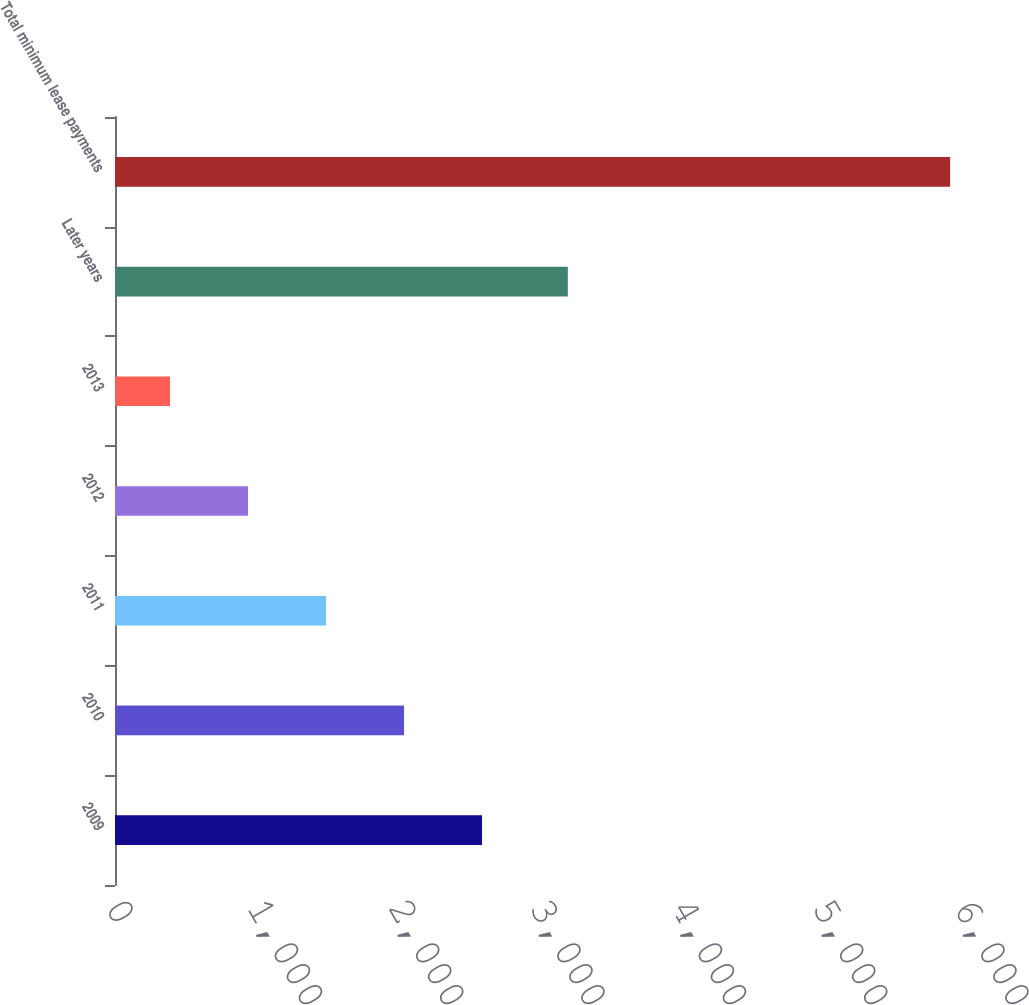<chart> <loc_0><loc_0><loc_500><loc_500><bar_chart><fcel>2009<fcel>2010<fcel>2011<fcel>2012<fcel>2013<fcel>Later years<fcel>Total minimum lease payments<nl><fcel>2597<fcel>2045<fcel>1493<fcel>941<fcel>389<fcel>3204<fcel>5909<nl></chart> 